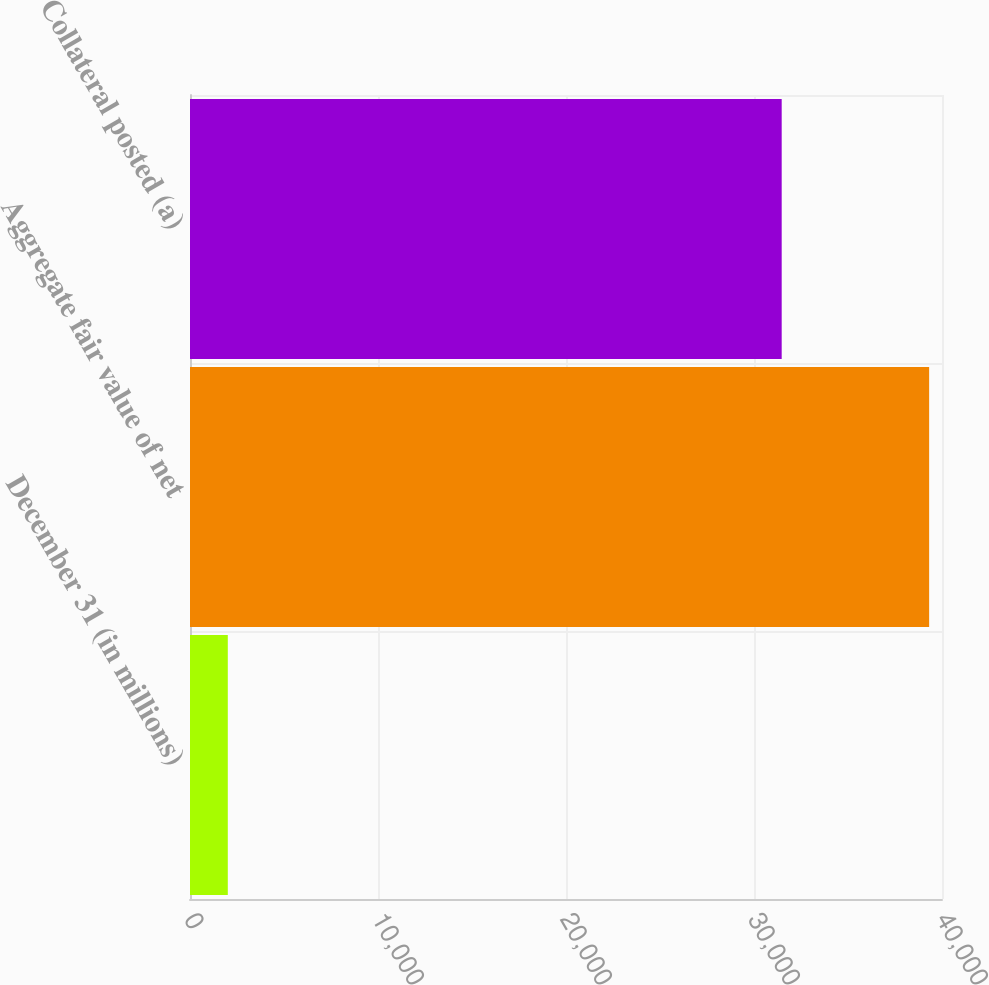Convert chart. <chart><loc_0><loc_0><loc_500><loc_500><bar_chart><fcel>December 31 (in millions)<fcel>Aggregate fair value of net<fcel>Collateral posted (a)<nl><fcel>2011<fcel>39316<fcel>31473<nl></chart> 